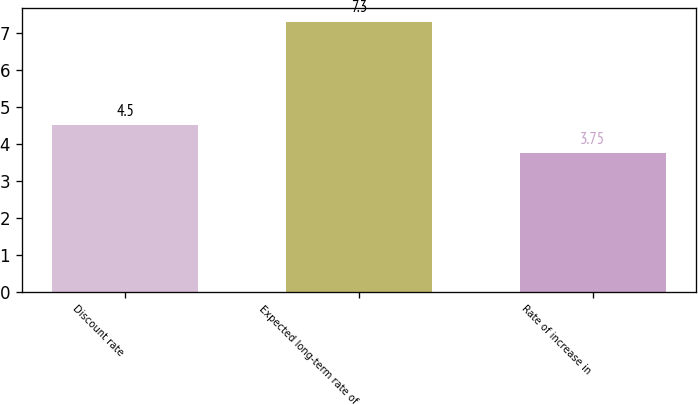<chart> <loc_0><loc_0><loc_500><loc_500><bar_chart><fcel>Discount rate<fcel>Expected long-term rate of<fcel>Rate of increase in<nl><fcel>4.5<fcel>7.3<fcel>3.75<nl></chart> 